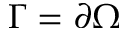Convert formula to latex. <formula><loc_0><loc_0><loc_500><loc_500>\Gamma = \partial \Omega</formula> 